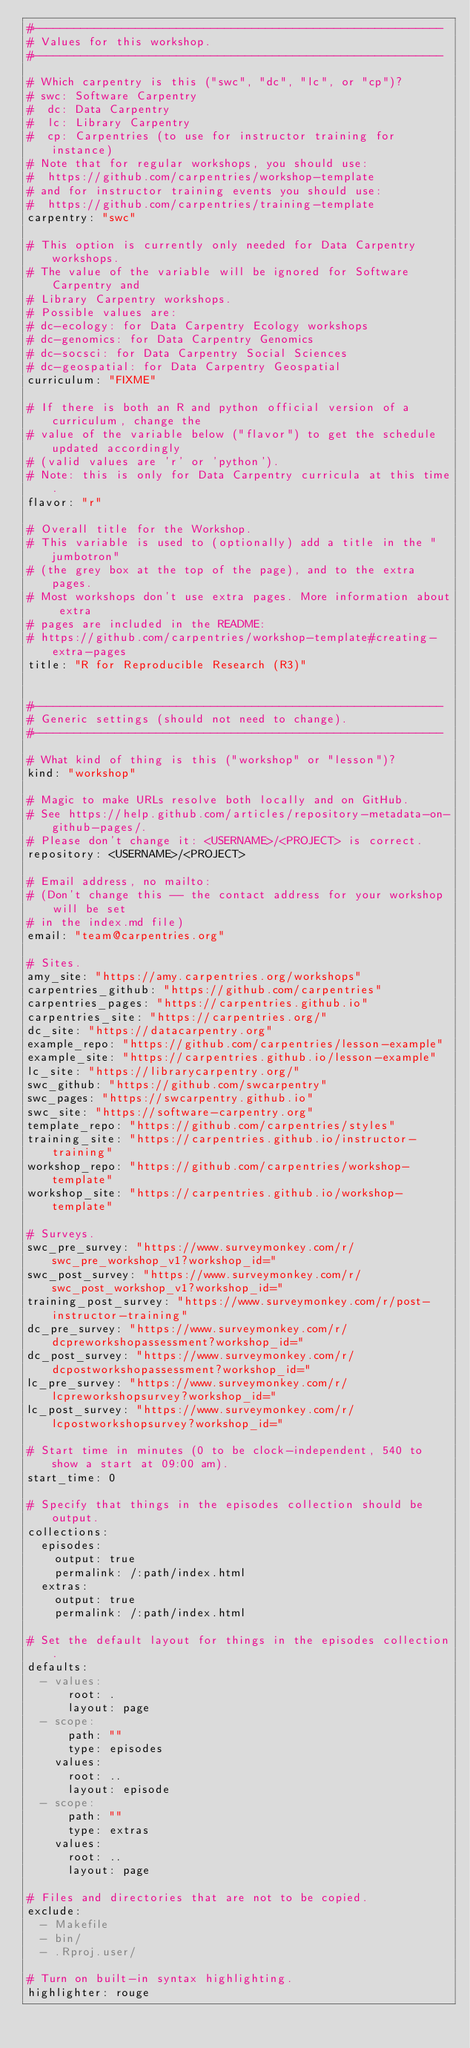<code> <loc_0><loc_0><loc_500><loc_500><_YAML_>#------------------------------------------------------------
# Values for this workshop.
#------------------------------------------------------------

# Which carpentry is this ("swc", "dc", "lc", or "cp")?
# swc: Software Carpentry
#  dc: Data Carpentry
#  lc: Library Carpentry
#  cp: Carpentries (to use for instructor training for instance)
# Note that for regular workshops, you should use:
#  https://github.com/carpentries/workshop-template
# and for instructor training events you should use:
#  https://github.com/carpentries/training-template
carpentry: "swc"

# This option is currently only needed for Data Carpentry workshops.
# The value of the variable will be ignored for Software Carpentry and
# Library Carpentry workshops.
# Possible values are:
# dc-ecology: for Data Carpentry Ecology workshops
# dc-genomics: for Data Carpentry Genomics
# dc-socsci: for Data Carpentry Social Sciences
# dc-geospatial: for Data Carpentry Geospatial
curriculum: "FIXME"

# If there is both an R and python official version of a curriculum, change the
# value of the variable below ("flavor") to get the schedule updated accordingly
# (valid values are 'r' or 'python').
# Note: this is only for Data Carpentry curricula at this time.
flavor: "r"

# Overall title for the Workshop.
# This variable is used to (optionally) add a title in the "jumbotron"
# (the grey box at the top of the page), and to the extra pages.
# Most workshops don't use extra pages. More information about extra
# pages are included in the README:
# https://github.com/carpentries/workshop-template#creating-extra-pages
title: "R for Reproducible Research (R3)"


#------------------------------------------------------------
# Generic settings (should not need to change).
#------------------------------------------------------------

# What kind of thing is this ("workshop" or "lesson")?
kind: "workshop"

# Magic to make URLs resolve both locally and on GitHub.
# See https://help.github.com/articles/repository-metadata-on-github-pages/.
# Please don't change it: <USERNAME>/<PROJECT> is correct.
repository: <USERNAME>/<PROJECT>

# Email address, no mailto:
# (Don't change this -- the contact address for your workshop will be set 
# in the index.md file)
email: "team@carpentries.org"

# Sites.
amy_site: "https://amy.carpentries.org/workshops"
carpentries_github: "https://github.com/carpentries"
carpentries_pages: "https://carpentries.github.io"
carpentries_site: "https://carpentries.org/"
dc_site: "https://datacarpentry.org"
example_repo: "https://github.com/carpentries/lesson-example"
example_site: "https://carpentries.github.io/lesson-example"
lc_site: "https://librarycarpentry.org/"
swc_github: "https://github.com/swcarpentry"
swc_pages: "https://swcarpentry.github.io"
swc_site: "https://software-carpentry.org"
template_repo: "https://github.com/carpentries/styles"
training_site: "https://carpentries.github.io/instructor-training"
workshop_repo: "https://github.com/carpentries/workshop-template"
workshop_site: "https://carpentries.github.io/workshop-template"

# Surveys.
swc_pre_survey: "https://www.surveymonkey.com/r/swc_pre_workshop_v1?workshop_id="
swc_post_survey: "https://www.surveymonkey.com/r/swc_post_workshop_v1?workshop_id="
training_post_survey: "https://www.surveymonkey.com/r/post-instructor-training"
dc_pre_survey: "https://www.surveymonkey.com/r/dcpreworkshopassessment?workshop_id="
dc_post_survey: "https://www.surveymonkey.com/r/dcpostworkshopassessment?workshop_id="
lc_pre_survey: "https://www.surveymonkey.com/r/lcpreworkshopsurvey?workshop_id="
lc_post_survey: "https://www.surveymonkey.com/r/lcpostworkshopsurvey?workshop_id="

# Start time in minutes (0 to be clock-independent, 540 to show a start at 09:00 am).
start_time: 0

# Specify that things in the episodes collection should be output.
collections:
  episodes:
    output: true
    permalink: /:path/index.html
  extras:
    output: true
    permalink: /:path/index.html

# Set the default layout for things in the episodes collection.
defaults:
  - values:
      root: .
      layout: page
  - scope:
      path: ""
      type: episodes
    values:
      root: ..
      layout: episode
  - scope:
      path: ""
      type: extras
    values:
      root: ..
      layout: page

# Files and directories that are not to be copied.
exclude:
  - Makefile
  - bin/
  - .Rproj.user/

# Turn on built-in syntax highlighting.
highlighter: rouge
</code> 